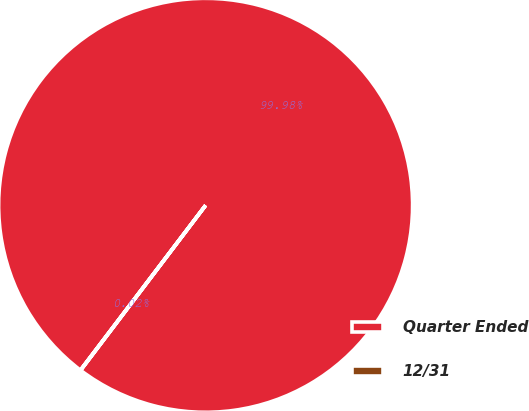Convert chart to OTSL. <chart><loc_0><loc_0><loc_500><loc_500><pie_chart><fcel>Quarter Ended<fcel>12/31<nl><fcel>99.98%<fcel>0.02%<nl></chart> 